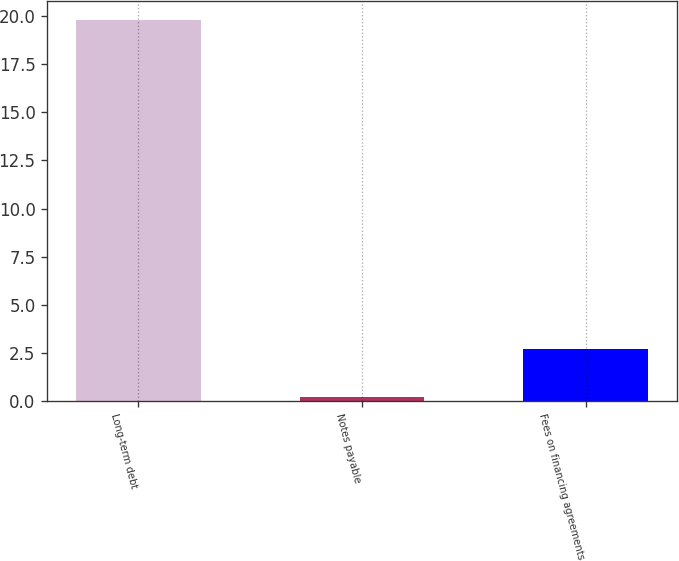<chart> <loc_0><loc_0><loc_500><loc_500><bar_chart><fcel>Long-term debt<fcel>Notes payable<fcel>Fees on financing agreements<nl><fcel>19.8<fcel>0.2<fcel>2.7<nl></chart> 